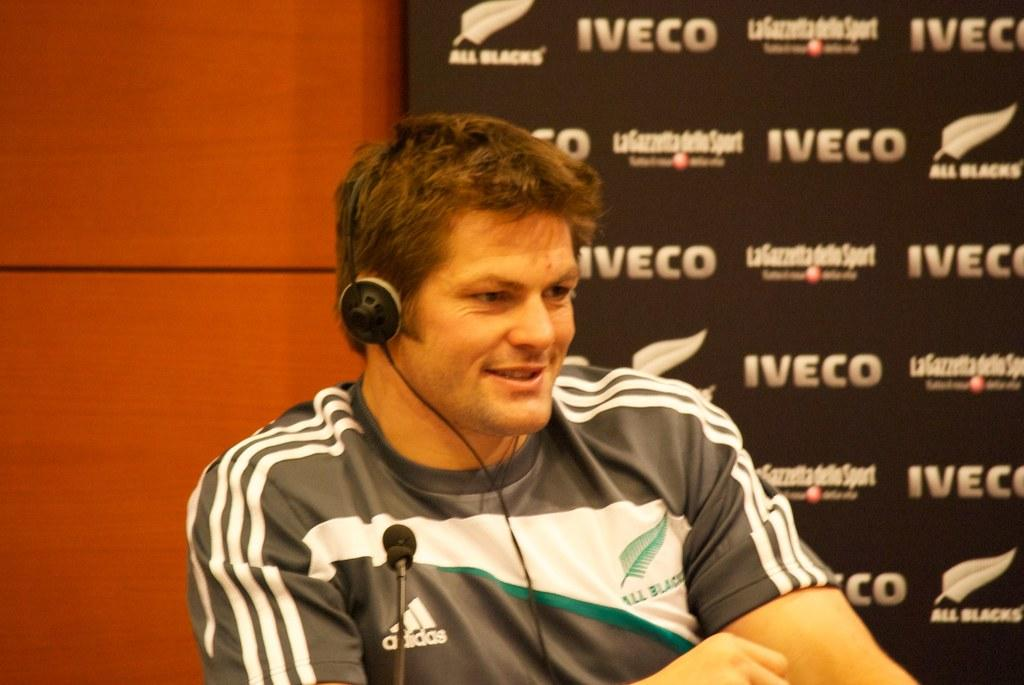<image>
Give a short and clear explanation of the subsequent image. A man sits with headphones on wearing an Adidas shirt and sitting in front of an advertisement board with Iveco and All Blacks on it. 